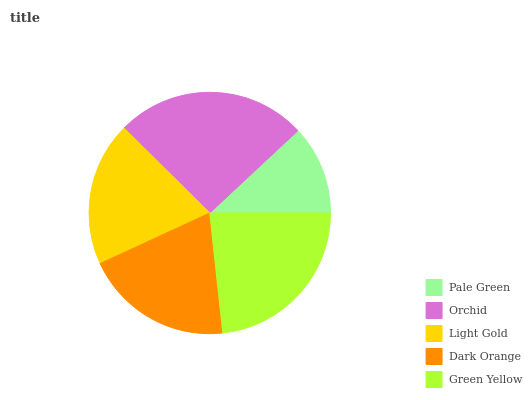Is Pale Green the minimum?
Answer yes or no. Yes. Is Orchid the maximum?
Answer yes or no. Yes. Is Light Gold the minimum?
Answer yes or no. No. Is Light Gold the maximum?
Answer yes or no. No. Is Orchid greater than Light Gold?
Answer yes or no. Yes. Is Light Gold less than Orchid?
Answer yes or no. Yes. Is Light Gold greater than Orchid?
Answer yes or no. No. Is Orchid less than Light Gold?
Answer yes or no. No. Is Dark Orange the high median?
Answer yes or no. Yes. Is Dark Orange the low median?
Answer yes or no. Yes. Is Pale Green the high median?
Answer yes or no. No. Is Pale Green the low median?
Answer yes or no. No. 